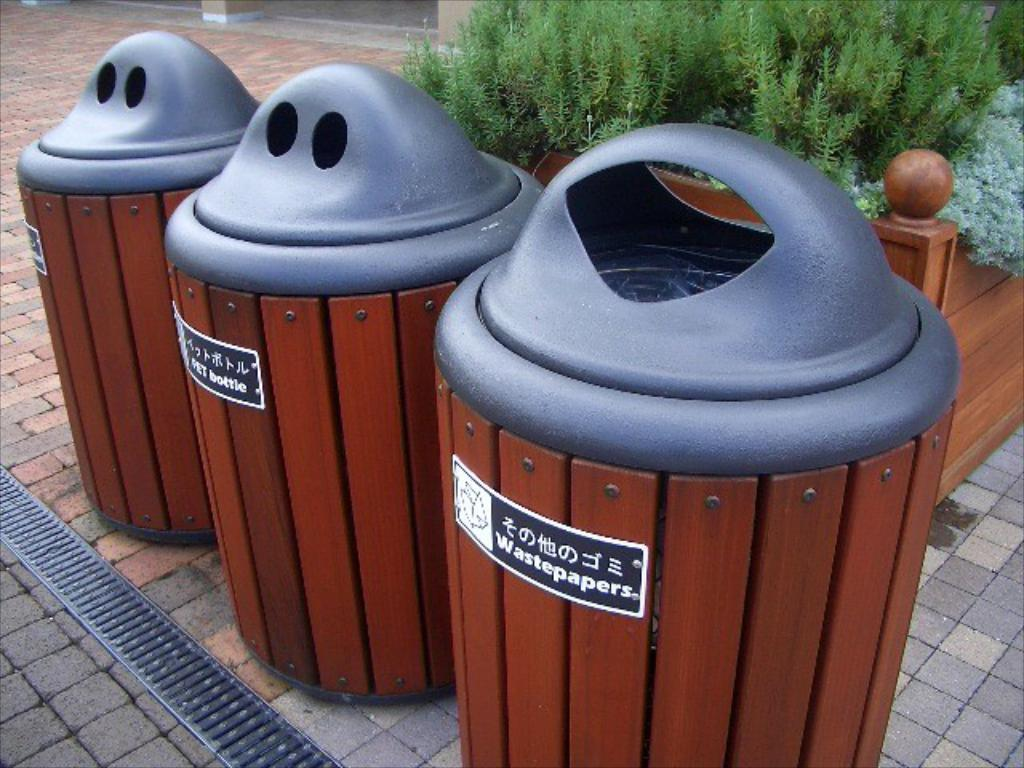Provide a one-sentence caption for the provided image. Three trash cans where one is for wastepapers and the other for bottles. 